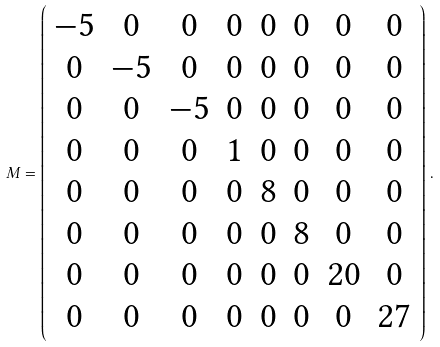<formula> <loc_0><loc_0><loc_500><loc_500>M = \left ( \begin{array} { c c c c c c c c } - 5 & 0 & 0 & 0 & 0 & 0 & 0 & 0 \\ 0 & - 5 & 0 & 0 & 0 & 0 & 0 & 0 \\ 0 & 0 & - 5 & 0 & 0 & 0 & 0 & 0 \\ 0 & 0 & 0 & 1 & 0 & 0 & 0 & 0 \\ 0 & 0 & 0 & 0 & 8 & 0 & 0 & 0 \\ 0 & 0 & 0 & 0 & 0 & 8 & 0 & 0 \\ 0 & 0 & 0 & 0 & 0 & 0 & 2 0 & 0 \\ 0 & 0 & 0 & 0 & 0 & 0 & 0 & 2 7 \end{array} \right ) \, .</formula> 